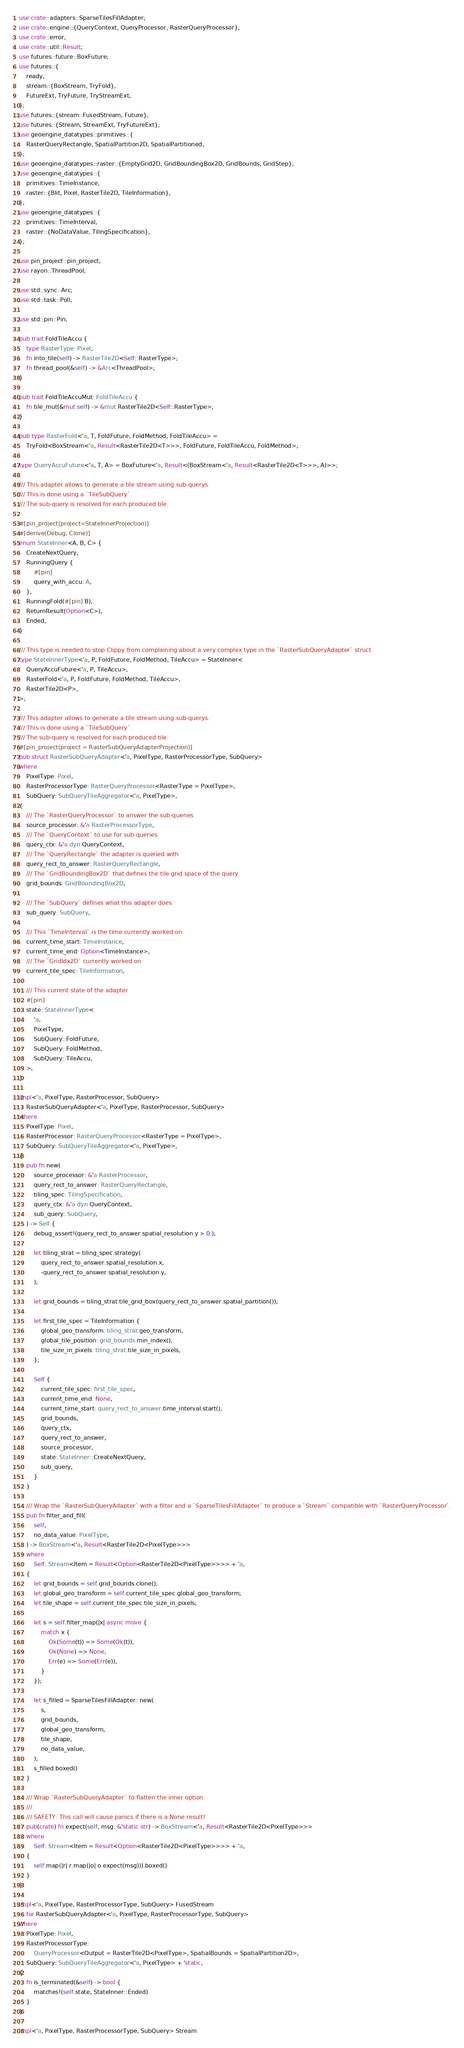Convert code to text. <code><loc_0><loc_0><loc_500><loc_500><_Rust_>use crate::adapters::SparseTilesFillAdapter;
use crate::engine::{QueryContext, QueryProcessor, RasterQueryProcessor};
use crate::error;
use crate::util::Result;
use futures::future::BoxFuture;
use futures::{
    ready,
    stream::{BoxStream, TryFold},
    FutureExt, TryFuture, TryStreamExt,
};
use futures::{stream::FusedStream, Future};
use futures::{Stream, StreamExt, TryFutureExt};
use geoengine_datatypes::primitives::{
    RasterQueryRectangle, SpatialPartition2D, SpatialPartitioned,
};
use geoengine_datatypes::raster::{EmptyGrid2D, GridBoundingBox2D, GridBounds, GridStep};
use geoengine_datatypes::{
    primitives::TimeInstance,
    raster::{Blit, Pixel, RasterTile2D, TileInformation},
};
use geoengine_datatypes::{
    primitives::TimeInterval,
    raster::{NoDataValue, TilingSpecification},
};

use pin_project::pin_project;
use rayon::ThreadPool;

use std::sync::Arc;
use std::task::Poll;

use std::pin::Pin;

pub trait FoldTileAccu {
    type RasterType: Pixel;
    fn into_tile(self) -> RasterTile2D<Self::RasterType>;
    fn thread_pool(&self) -> &Arc<ThreadPool>;
}

pub trait FoldTileAccuMut: FoldTileAccu {
    fn tile_mut(&mut self) -> &mut RasterTile2D<Self::RasterType>;
}

pub type RasterFold<'a, T, FoldFuture, FoldMethod, FoldTileAccu> =
    TryFold<BoxStream<'a, Result<RasterTile2D<T>>>, FoldFuture, FoldTileAccu, FoldMethod>;

type QueryAccuFuture<'a, T, A> = BoxFuture<'a, Result<(BoxStream<'a, Result<RasterTile2D<T>>>, A)>>;

/// This adapter allows to generate a tile stream using sub-querys.
/// This is done using a `TileSubQuery`.
/// The sub-query is resolved for each produced tile.

#[pin_project(project=StateInnerProjection)]
#[derive(Debug, Clone)]
enum StateInner<A, B, C> {
    CreateNextQuery,
    RunningQuery {
        #[pin]
        query_with_accu: A,
    },
    RunningFold(#[pin] B),
    ReturnResult(Option<C>),
    Ended,
}

/// This type is needed to stop Clippy from complaining about a very complex type in the `RasterSubQueryAdapter` struct.
type StateInnerType<'a, P, FoldFuture, FoldMethod, TileAccu> = StateInner<
    QueryAccuFuture<'a, P, TileAccu>,
    RasterFold<'a, P, FoldFuture, FoldMethod, TileAccu>,
    RasterTile2D<P>,
>;

/// This adapter allows to generate a tile stream using sub-querys.
/// This is done using a `TileSubQuery`.
/// The sub-query is resolved for each produced tile.
#[pin_project(project = RasterSubQueryAdapterProjection)]
pub struct RasterSubQueryAdapter<'a, PixelType, RasterProcessorType, SubQuery>
where
    PixelType: Pixel,
    RasterProcessorType: RasterQueryProcessor<RasterType = PixelType>,
    SubQuery: SubQueryTileAggregator<'a, PixelType>,
{
    /// The `RasterQueryProcessor` to answer the sub-queries
    source_processor: &'a RasterProcessorType,
    /// The `QueryContext` to use for sub-queries
    query_ctx: &'a dyn QueryContext,
    /// The `QueryRectangle` the adapter is queried with
    query_rect_to_answer: RasterQueryRectangle,
    /// The `GridBoundingBox2D` that defines the tile grid space of the query.
    grid_bounds: GridBoundingBox2D,

    /// The `SubQuery` defines what this adapter does.
    sub_query: SubQuery,

    /// This `TimeInterval` is the time currently worked on
    current_time_start: TimeInstance,
    current_time_end: Option<TimeInstance>,
    /// The `GridIdx2D` currently worked on
    current_tile_spec: TileInformation,

    /// This current state of the adapter
    #[pin]
    state: StateInnerType<
        'a,
        PixelType,
        SubQuery::FoldFuture,
        SubQuery::FoldMethod,
        SubQuery::TileAccu,
    >,
}

impl<'a, PixelType, RasterProcessor, SubQuery>
    RasterSubQueryAdapter<'a, PixelType, RasterProcessor, SubQuery>
where
    PixelType: Pixel,
    RasterProcessor: RasterQueryProcessor<RasterType = PixelType>,
    SubQuery: SubQueryTileAggregator<'a, PixelType>,
{
    pub fn new(
        source_processor: &'a RasterProcessor,
        query_rect_to_answer: RasterQueryRectangle,
        tiling_spec: TilingSpecification,
        query_ctx: &'a dyn QueryContext,
        sub_query: SubQuery,
    ) -> Self {
        debug_assert!(query_rect_to_answer.spatial_resolution.y > 0.);

        let tiling_strat = tiling_spec.strategy(
            query_rect_to_answer.spatial_resolution.x,
            -query_rect_to_answer.spatial_resolution.y,
        );

        let grid_bounds = tiling_strat.tile_grid_box(query_rect_to_answer.spatial_partition());

        let first_tile_spec = TileInformation {
            global_geo_transform: tiling_strat.geo_transform,
            global_tile_position: grid_bounds.min_index(),
            tile_size_in_pixels: tiling_strat.tile_size_in_pixels,
        };

        Self {
            current_tile_spec: first_tile_spec,
            current_time_end: None,
            current_time_start: query_rect_to_answer.time_interval.start(),
            grid_bounds,
            query_ctx,
            query_rect_to_answer,
            source_processor,
            state: StateInner::CreateNextQuery,
            sub_query,
        }
    }

    /// Wrap the `RasterSubQueryAdapter` with a filter and a `SparseTilesFillAdapter` to produce a `Stream` compatible with `RasterQueryProcessor`.
    pub fn filter_and_fill(
        self,
        no_data_value: PixelType,
    ) -> BoxStream<'a, Result<RasterTile2D<PixelType>>>
    where
        Self: Stream<Item = Result<Option<RasterTile2D<PixelType>>>> + 'a,
    {
        let grid_bounds = self.grid_bounds.clone();
        let global_geo_transform = self.current_tile_spec.global_geo_transform;
        let tile_shape = self.current_tile_spec.tile_size_in_pixels;

        let s = self.filter_map(|x| async move {
            match x {
                Ok(Some(t)) => Some(Ok(t)),
                Ok(None) => None,
                Err(e) => Some(Err(e)),
            }
        });

        let s_filled = SparseTilesFillAdapter::new(
            s,
            grid_bounds,
            global_geo_transform,
            tile_shape,
            no_data_value,
        );
        s_filled.boxed()
    }

    /// Wrap `RasterSubQueryAdapter` to flatten the inner option.
    ///
    /// SAFETY: This call will cause panics if there is a None result!
    pub(crate) fn expect(self, msg: &'static str) -> BoxStream<'a, Result<RasterTile2D<PixelType>>>
    where
        Self: Stream<Item = Result<Option<RasterTile2D<PixelType>>>> + 'a,
    {
        self.map(|r| r.map(|o| o.expect(msg))).boxed()
    }
}

impl<'a, PixelType, RasterProcessorType, SubQuery> FusedStream
    for RasterSubQueryAdapter<'a, PixelType, RasterProcessorType, SubQuery>
where
    PixelType: Pixel,
    RasterProcessorType:
        QueryProcessor<Output = RasterTile2D<PixelType>, SpatialBounds = SpatialPartition2D>,
    SubQuery: SubQueryTileAggregator<'a, PixelType> + 'static,
{
    fn is_terminated(&self) -> bool {
        matches!(self.state, StateInner::Ended)
    }
}

impl<'a, PixelType, RasterProcessorType, SubQuery> Stream</code> 